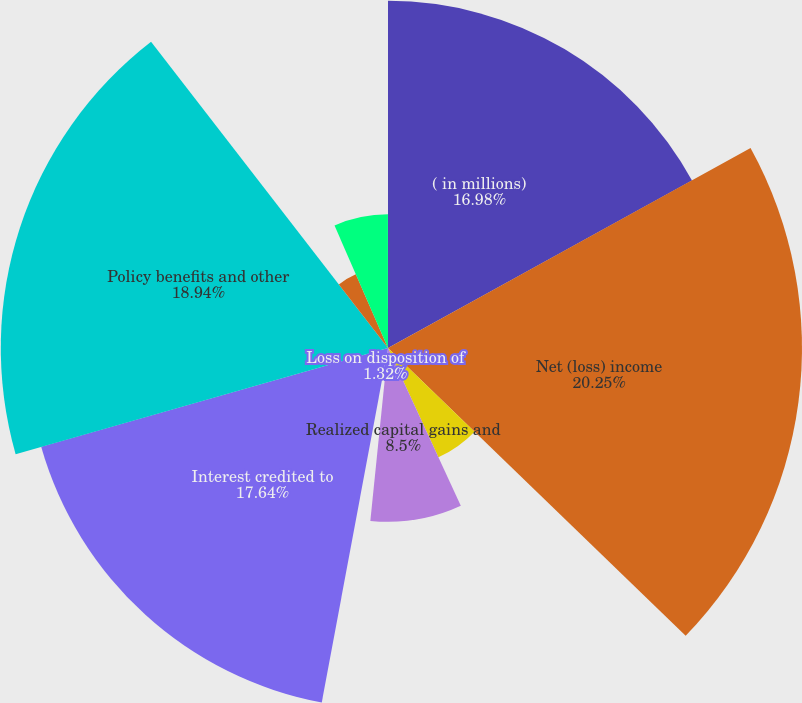Convert chart. <chart><loc_0><loc_0><loc_500><loc_500><pie_chart><fcel>( in millions)<fcel>Net (loss) income<fcel>Depreciation amortization and<fcel>Realized capital gains and<fcel>Loss on disposition of<fcel>Interest credited to<fcel>Policy benefits and other<fcel>Unearned premiums<fcel>Deferred policy acquisition<fcel>Premium installment<nl><fcel>16.98%<fcel>20.25%<fcel>5.89%<fcel>8.5%<fcel>1.32%<fcel>17.64%<fcel>18.94%<fcel>3.93%<fcel>6.54%<fcel>0.01%<nl></chart> 